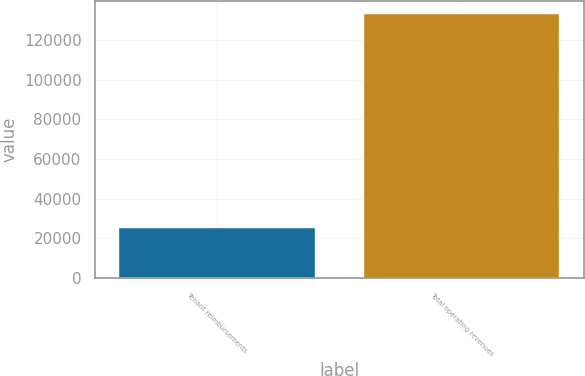Convert chart. <chart><loc_0><loc_0><loc_500><loc_500><bar_chart><fcel>Tenant reimbursements<fcel>Total operating revenues<nl><fcel>25439<fcel>133112<nl></chart> 